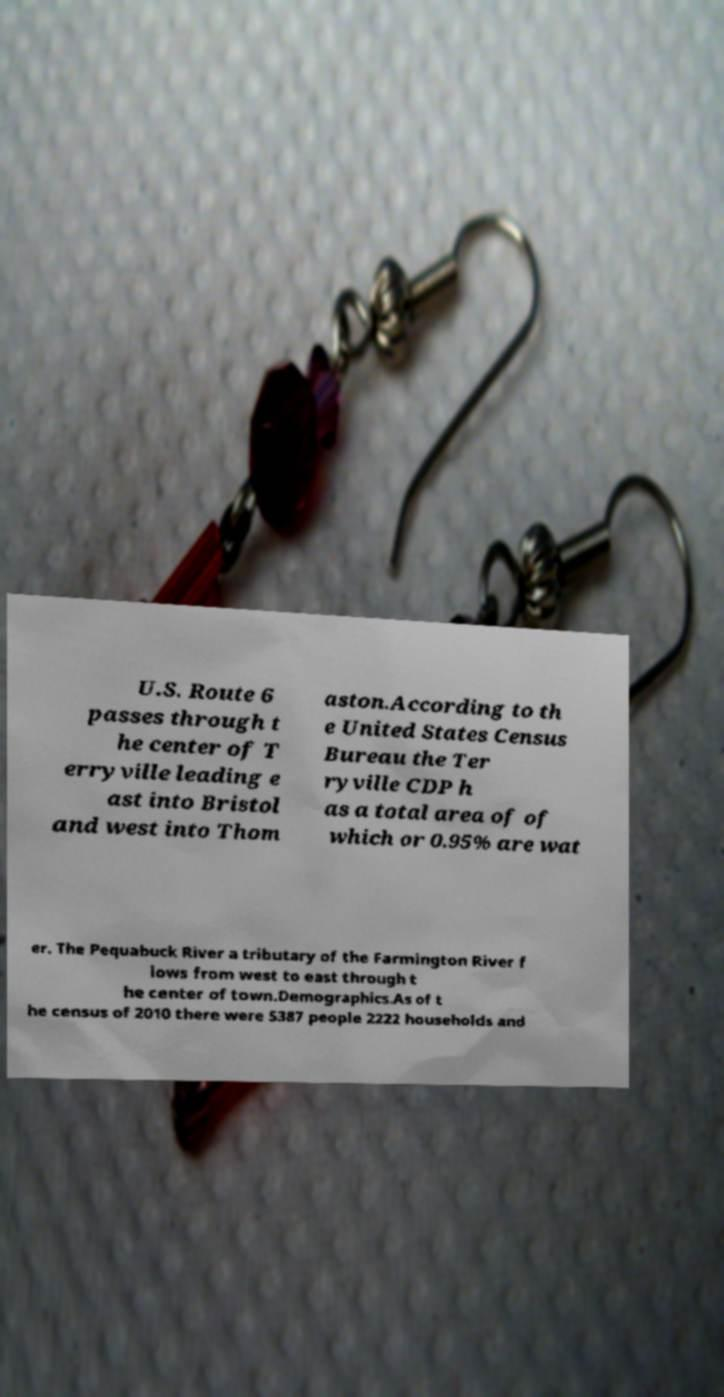Can you accurately transcribe the text from the provided image for me? U.S. Route 6 passes through t he center of T erryville leading e ast into Bristol and west into Thom aston.According to th e United States Census Bureau the Ter ryville CDP h as a total area of of which or 0.95% are wat er. The Pequabuck River a tributary of the Farmington River f lows from west to east through t he center of town.Demographics.As of t he census of 2010 there were 5387 people 2222 households and 